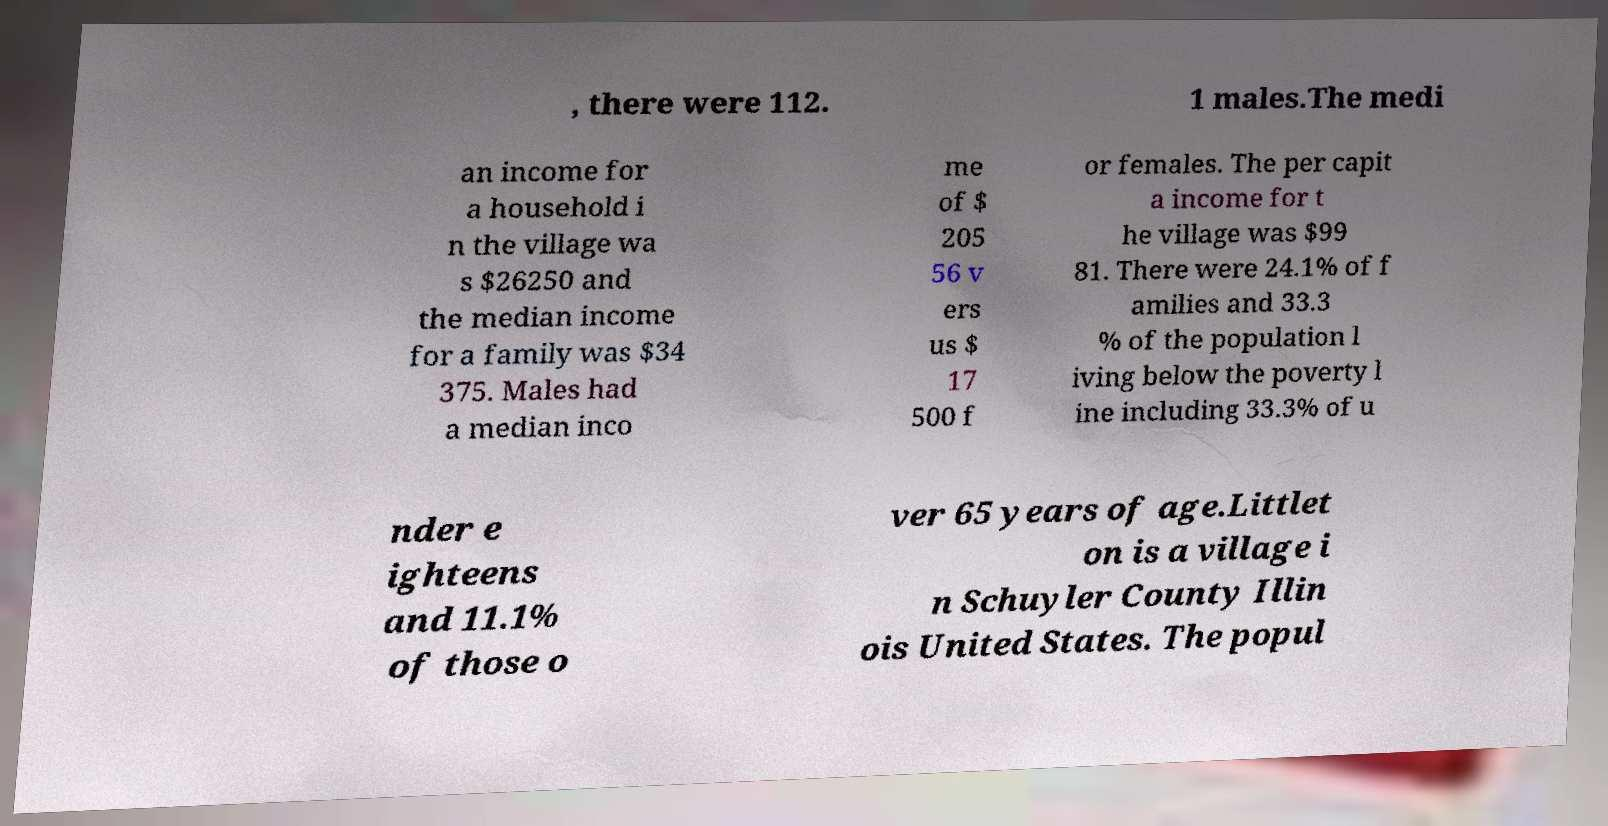Please identify and transcribe the text found in this image. , there were 112. 1 males.The medi an income for a household i n the village wa s $26250 and the median income for a family was $34 375. Males had a median inco me of $ 205 56 v ers us $ 17 500 f or females. The per capit a income for t he village was $99 81. There were 24.1% of f amilies and 33.3 % of the population l iving below the poverty l ine including 33.3% of u nder e ighteens and 11.1% of those o ver 65 years of age.Littlet on is a village i n Schuyler County Illin ois United States. The popul 